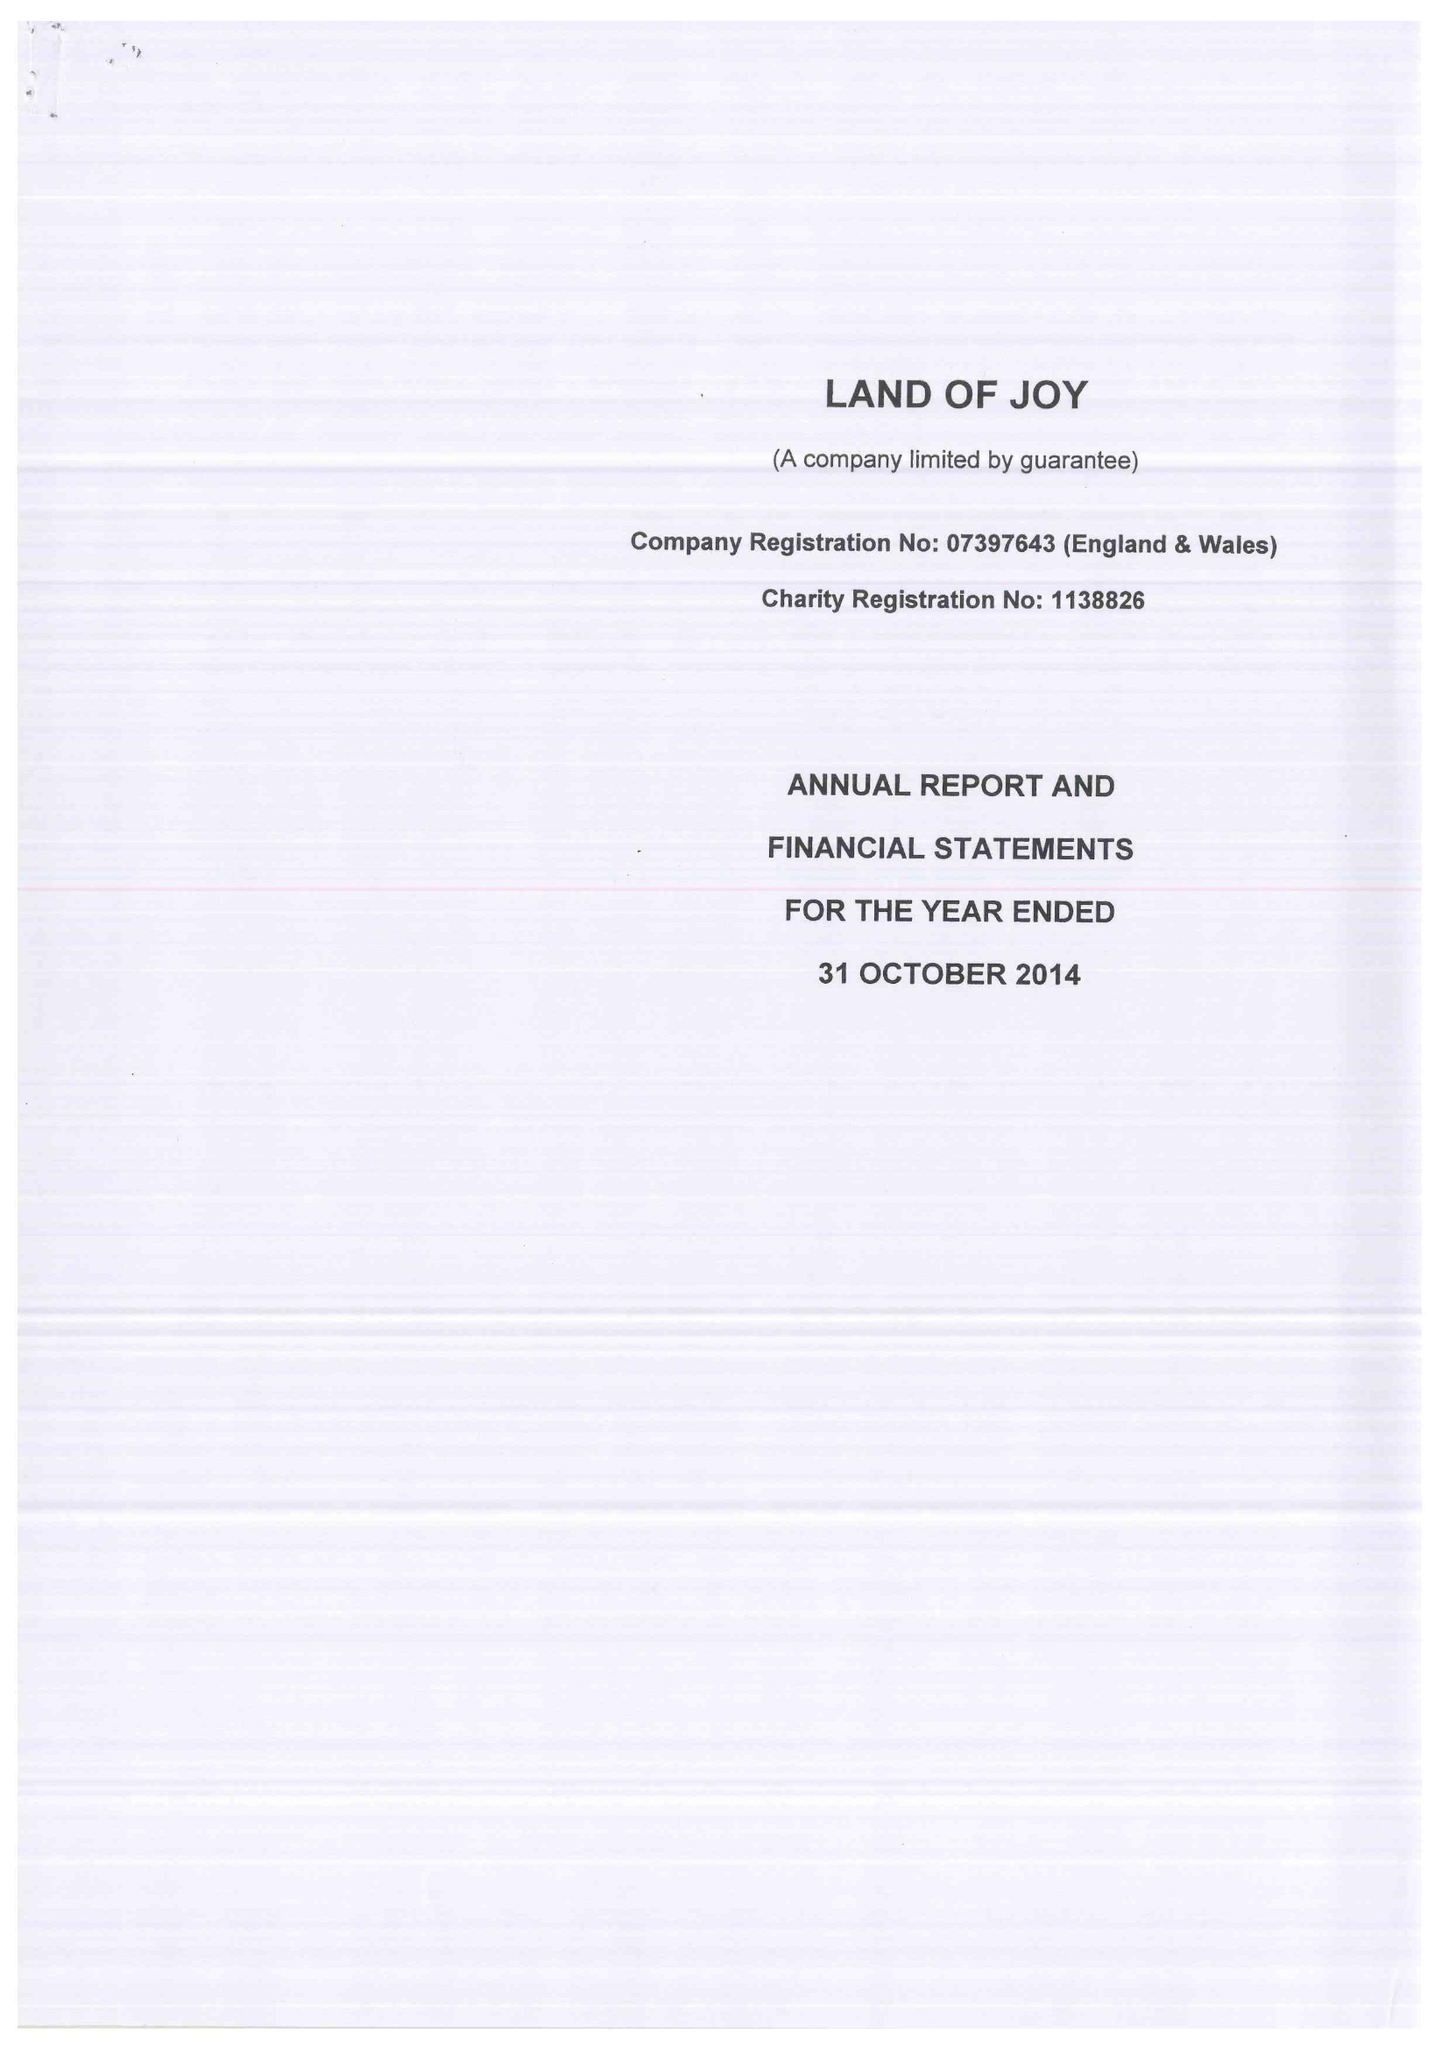What is the value for the income_annually_in_british_pounds?
Answer the question using a single word or phrase. 1228873.00 